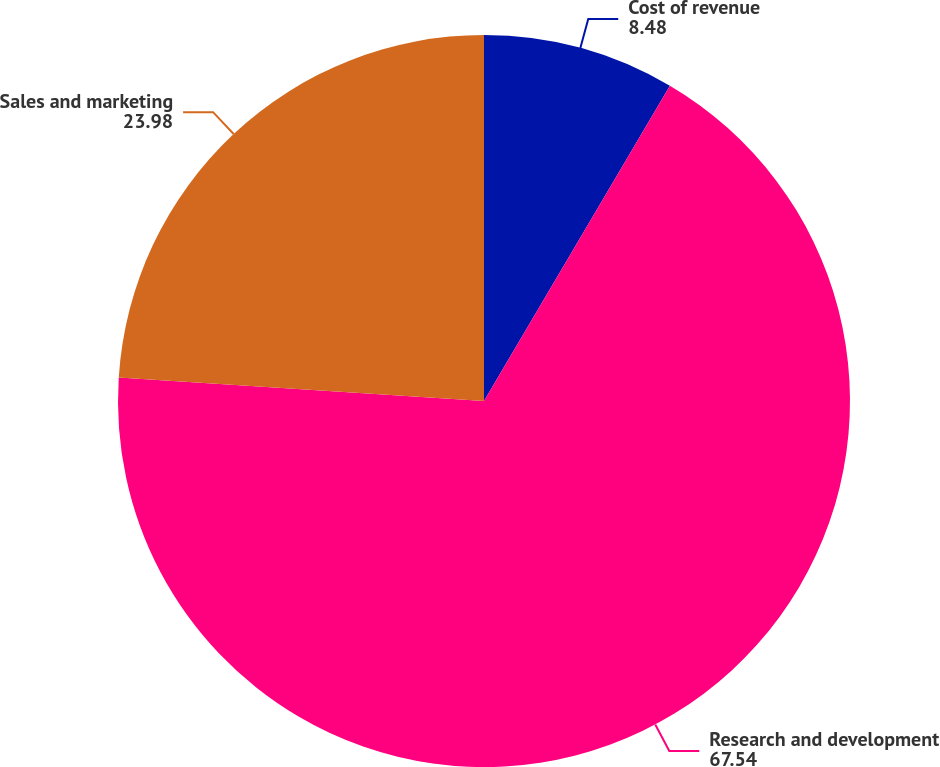Convert chart to OTSL. <chart><loc_0><loc_0><loc_500><loc_500><pie_chart><fcel>Cost of revenue<fcel>Research and development<fcel>Sales and marketing<nl><fcel>8.48%<fcel>67.54%<fcel>23.98%<nl></chart> 